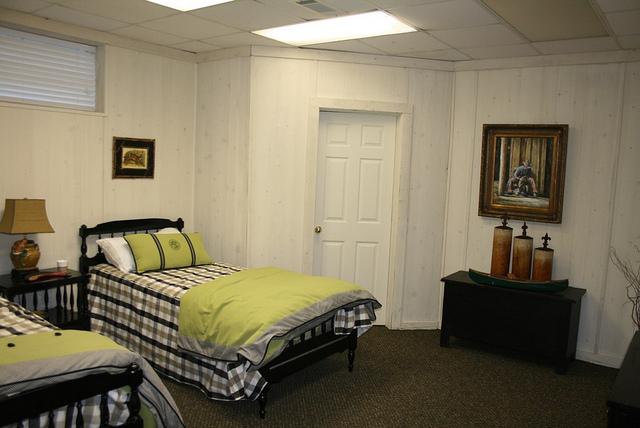Are there people sleeping in these beds?
Keep it brief. No. What is the main color on the bed?
Be succinct. Green. Is that a drop ceiling?
Keep it brief. Yes. 